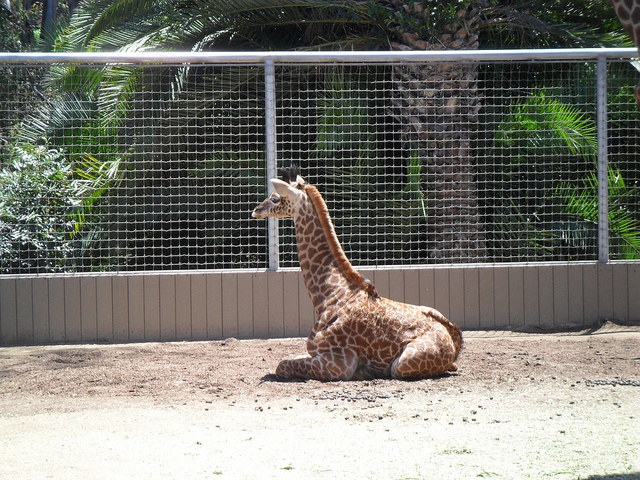Describe the objects in this image and their specific colors. I can see a giraffe in black, maroon, gray, and ivory tones in this image. 